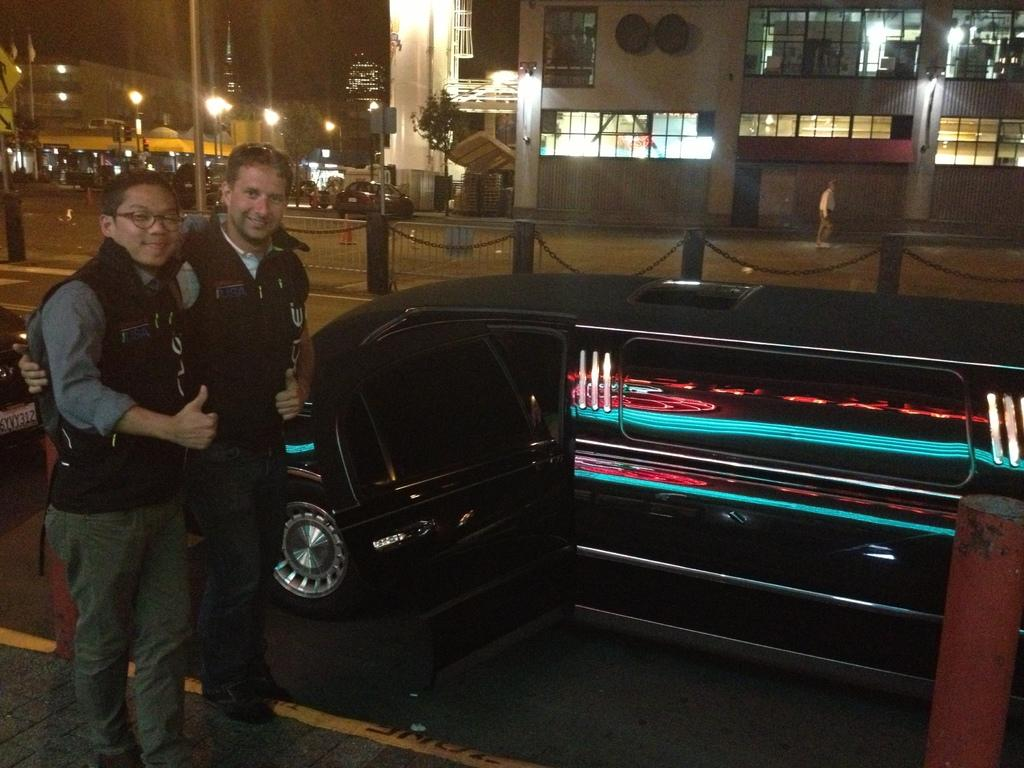What are the men in the image doing? The men in the image are standing on the road. What else can be seen on the road besides the men? Motor vehicles are present on the road. What type of cooking equipment is visible in the image? Grills are visible in the image. What safety feature is present on the road? Barrier poles are present in the image. What type of structures can be seen in the image? Buildings are visible in the image. What type of lighting is present in the image? Electric lights and street lights are present in the image. What type of poles are visible in the image? Street poles are visible in the image. What type of waste disposal containers are present on the road? Bins are present on the road. How do the men in the image join the fireman's team? There is no mention of a fireman's team or any firefighting activity in the image. What type of dance move do the men in the image perform? There is no indication of any dancing or movement in the image; the men are simply standing on the road. 